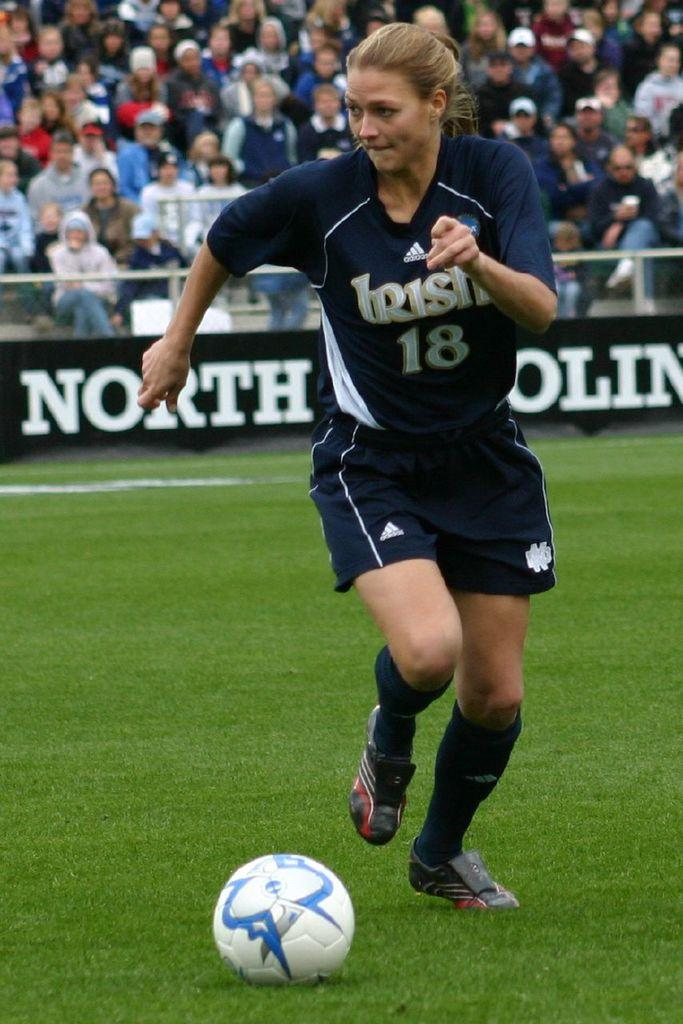Who is the main subject in the image? There is a girl in the image. What is the girl doing in the image? The girl is playing football. What can be seen in the background of the image? There is a fence and people sitting in a stadium in the background of the image. Can you see a receipt in the girl's hand while she is playing football? There is no receipt visible in the girl's hand or anywhere else in the image. 